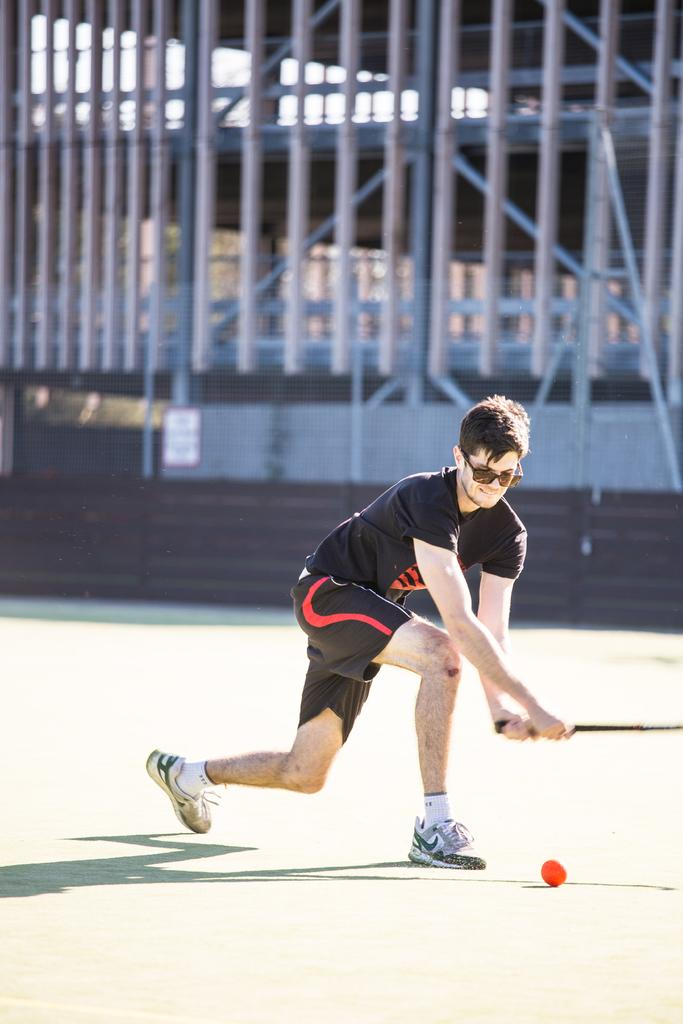Who is the main subject in the image? There is a boy in the image. What is the boy doing in the image? The boy is about to hit a ball. Where is the ball located in relation to the boy? The ball is in front of the boy. What can be observed about the background of the image? The background of the boy is blurred. How many chickens are visible in the image? There are no chickens present in the image. What type of waves can be seen in the background of the image? There are no waves visible in the image; the background is blurred. 